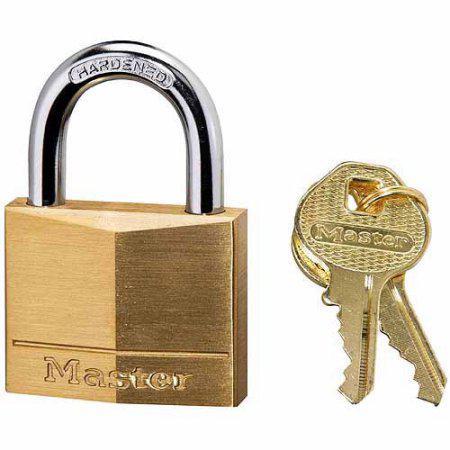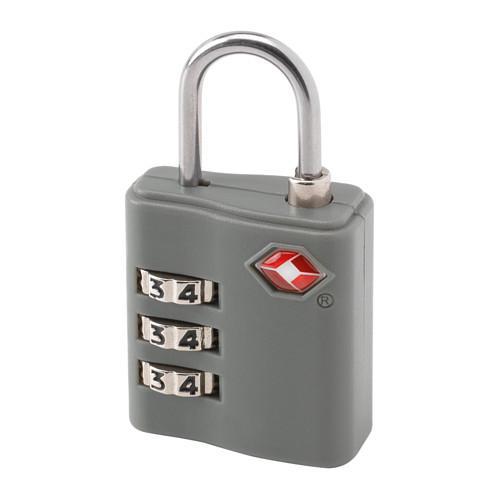The first image is the image on the left, the second image is the image on the right. For the images shown, is this caption "At least one of the padlocks is numbered." true? Answer yes or no. Yes. The first image is the image on the left, the second image is the image on the right. Assess this claim about the two images: "Two gold keys sit to the right of a silver padlock with a blue base.". Correct or not? Answer yes or no. No. 